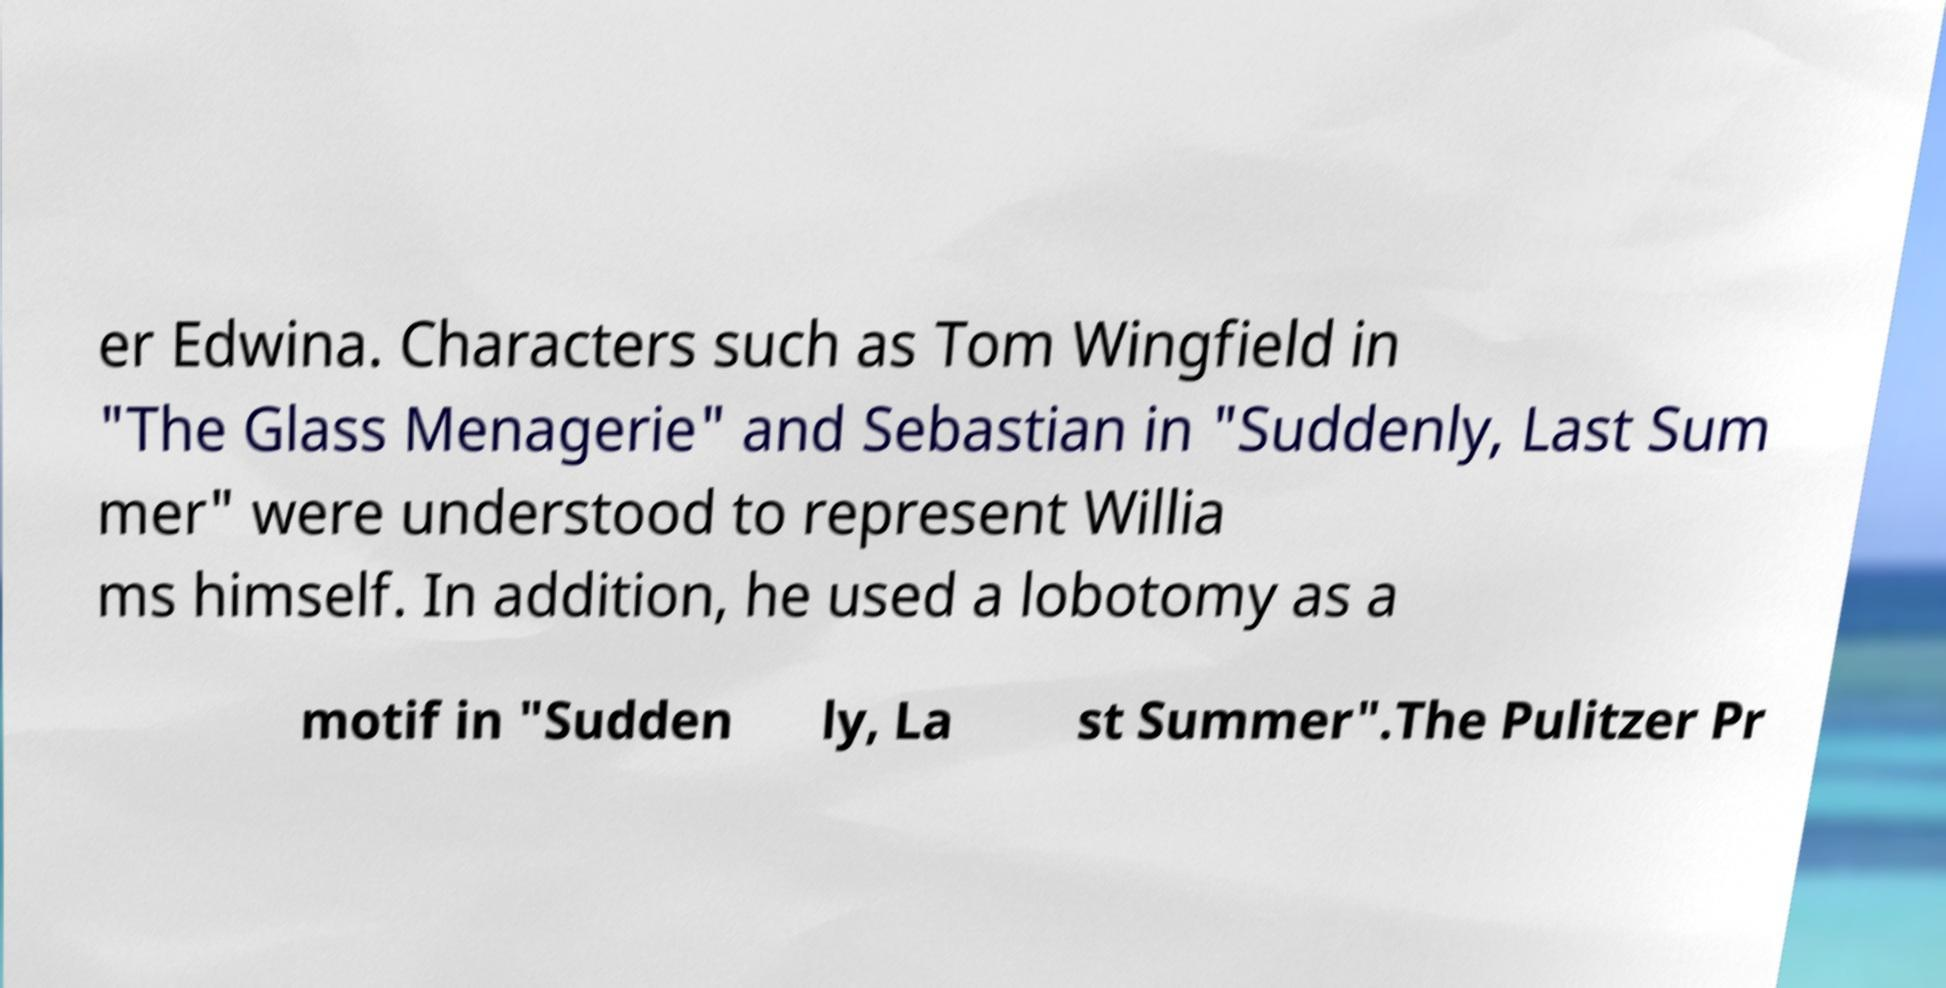Can you read and provide the text displayed in the image?This photo seems to have some interesting text. Can you extract and type it out for me? er Edwina. Characters such as Tom Wingfield in "The Glass Menagerie" and Sebastian in "Suddenly, Last Sum mer" were understood to represent Willia ms himself. In addition, he used a lobotomy as a motif in "Sudden ly, La st Summer".The Pulitzer Pr 